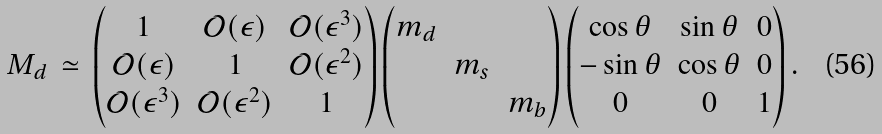Convert formula to latex. <formula><loc_0><loc_0><loc_500><loc_500>M _ { d } \, \simeq \, \begin{pmatrix} 1 & \mathcal { O } ( \epsilon ) & \mathcal { O } ( \epsilon ^ { 3 } ) \\ \mathcal { O } ( \epsilon ) & 1 & \mathcal { O } ( \epsilon ^ { 2 } ) \\ \mathcal { O } ( \epsilon ^ { 3 } ) & \mathcal { O } ( \epsilon ^ { 2 } ) & 1 \end{pmatrix} \begin{pmatrix} m _ { d } & & \\ & m _ { s } & \\ & & m _ { b } \end{pmatrix} \begin{pmatrix} \cos \theta & \sin \theta & 0 \\ - \sin \theta & \cos \theta & 0 \\ 0 & 0 & 1 \end{pmatrix} .</formula> 